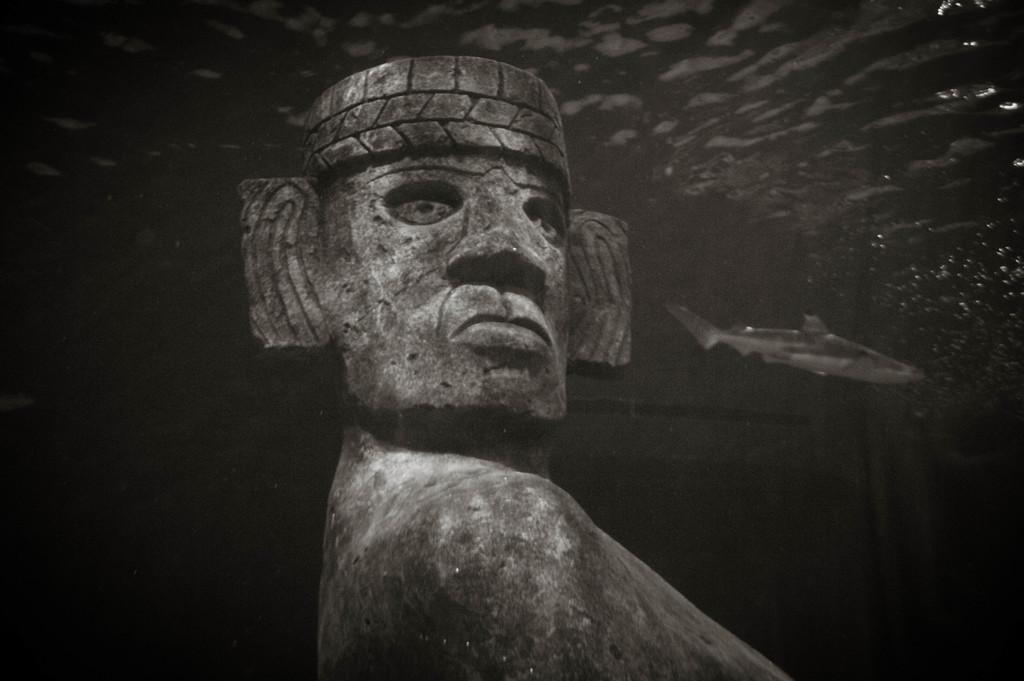What is the main subject of the image? There is a sculpture of a person in the image. What other object can be seen on the right side of the image? There is a fish on the right side of the image. What color is the background of the image? The background of the image is black. What type of weather can be seen in the image? There is no weather depicted in the image, as it is a sculpture and a fish on a black background. Can you tell me how many rabbits are present in the image? There are no rabbits present in the image; it features a sculpture of a person and a fish on a black background. 